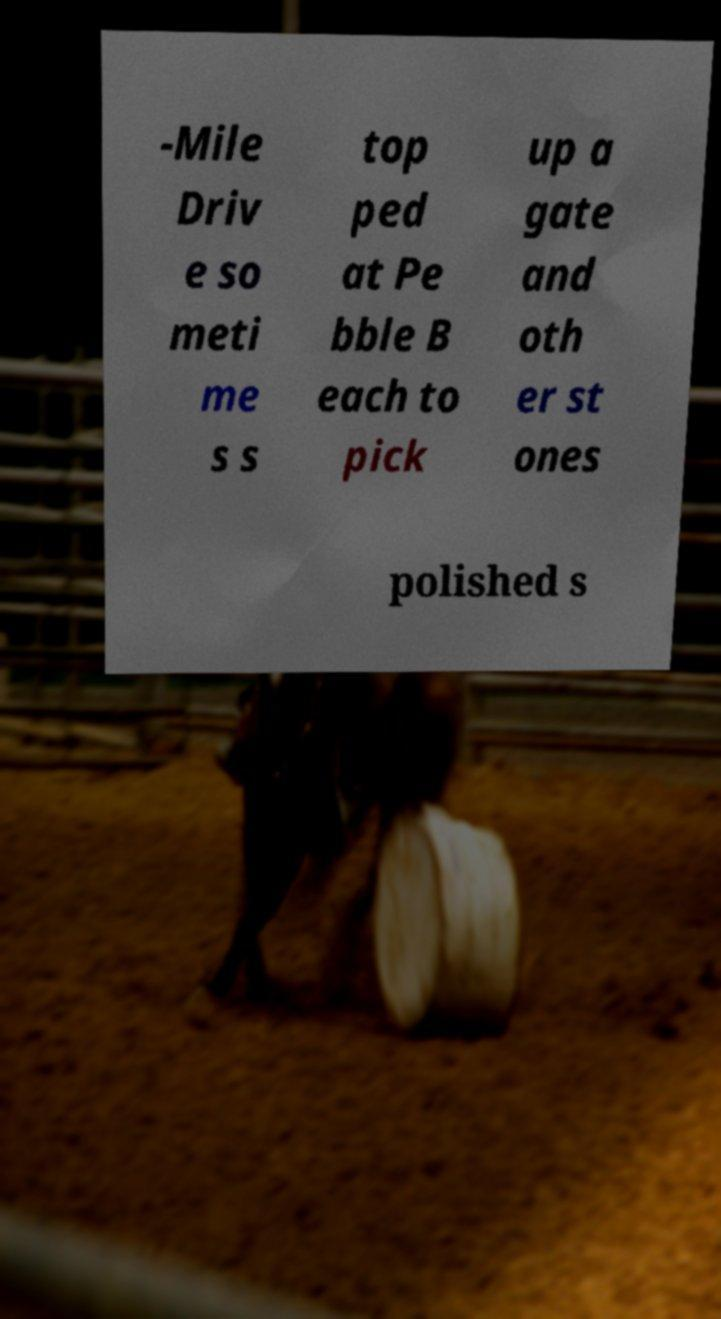Can you read and provide the text displayed in the image?This photo seems to have some interesting text. Can you extract and type it out for me? -Mile Driv e so meti me s s top ped at Pe bble B each to pick up a gate and oth er st ones polished s 